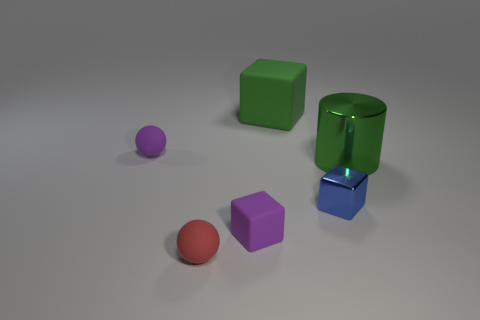Add 3 green things. How many objects exist? 9 Subtract all cylinders. How many objects are left? 5 Subtract 0 purple cylinders. How many objects are left? 6 Subtract all big green spheres. Subtract all tiny blue metal objects. How many objects are left? 5 Add 1 purple things. How many purple things are left? 3 Add 5 metal cubes. How many metal cubes exist? 6 